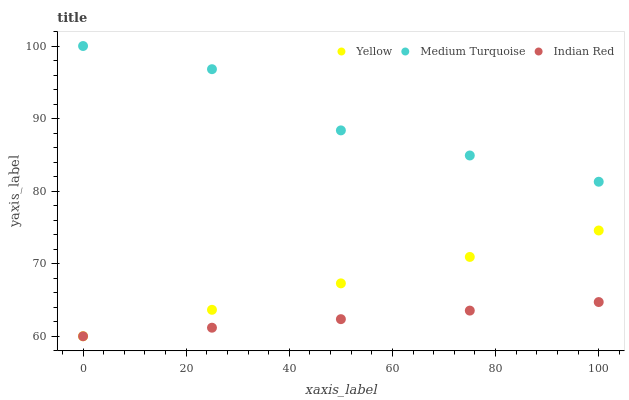Does Indian Red have the minimum area under the curve?
Answer yes or no. Yes. Does Medium Turquoise have the maximum area under the curve?
Answer yes or no. Yes. Does Yellow have the minimum area under the curve?
Answer yes or no. No. Does Yellow have the maximum area under the curve?
Answer yes or no. No. Is Indian Red the smoothest?
Answer yes or no. Yes. Is Medium Turquoise the roughest?
Answer yes or no. Yes. Is Medium Turquoise the smoothest?
Answer yes or no. No. Is Yellow the roughest?
Answer yes or no. No. Does Indian Red have the lowest value?
Answer yes or no. Yes. Does Medium Turquoise have the lowest value?
Answer yes or no. No. Does Medium Turquoise have the highest value?
Answer yes or no. Yes. Does Yellow have the highest value?
Answer yes or no. No. Is Yellow less than Medium Turquoise?
Answer yes or no. Yes. Is Medium Turquoise greater than Yellow?
Answer yes or no. Yes. Does Indian Red intersect Yellow?
Answer yes or no. Yes. Is Indian Red less than Yellow?
Answer yes or no. No. Is Indian Red greater than Yellow?
Answer yes or no. No. Does Yellow intersect Medium Turquoise?
Answer yes or no. No. 